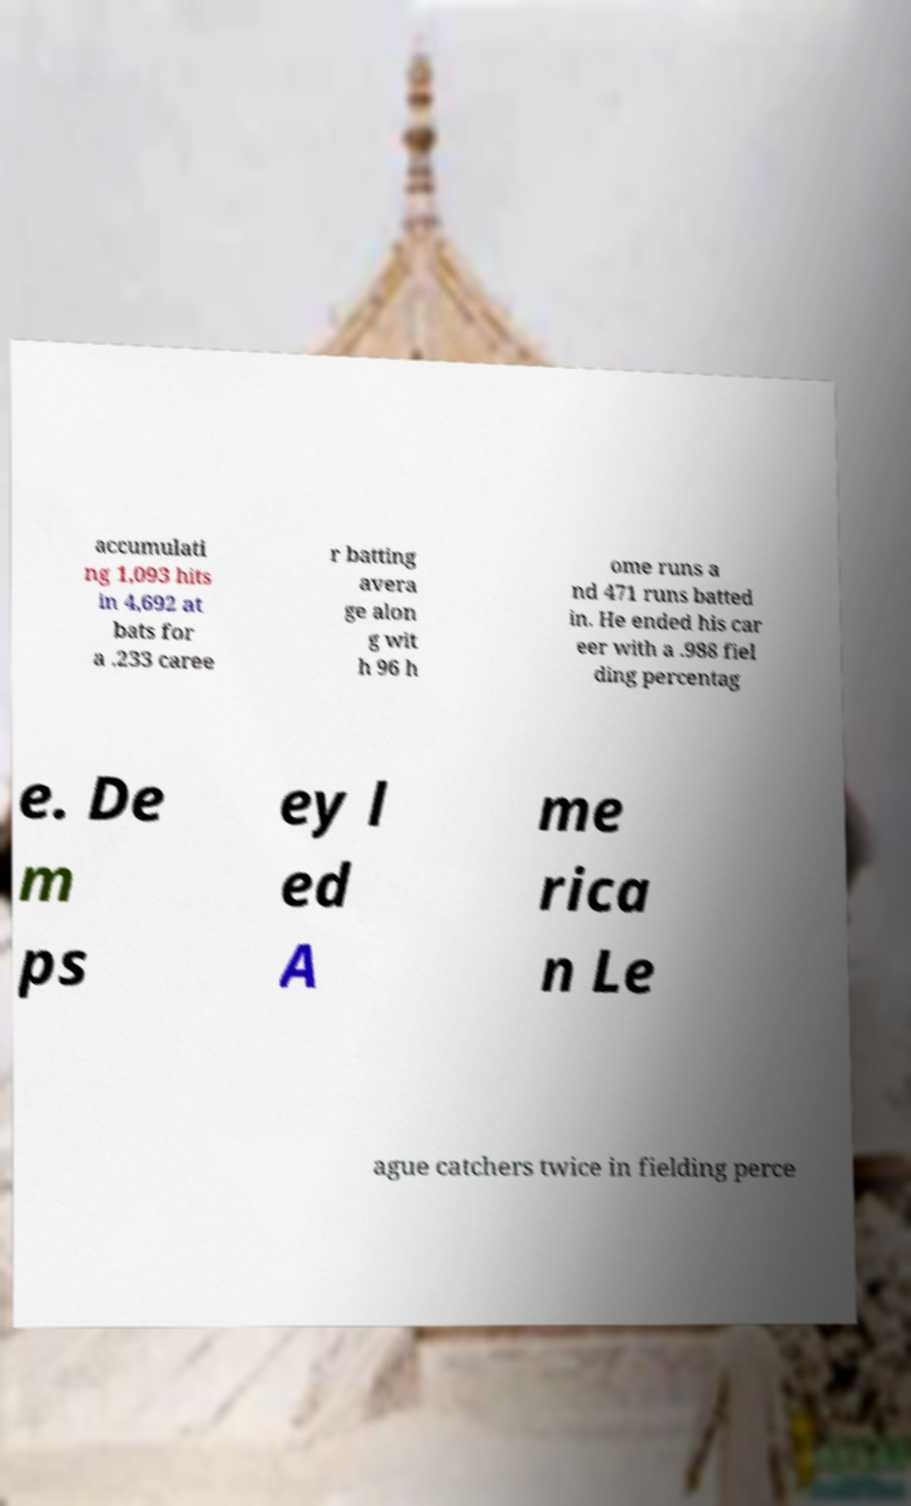I need the written content from this picture converted into text. Can you do that? accumulati ng 1,093 hits in 4,692 at bats for a .233 caree r batting avera ge alon g wit h 96 h ome runs a nd 471 runs batted in. He ended his car eer with a .988 fiel ding percentag e. De m ps ey l ed A me rica n Le ague catchers twice in fielding perce 